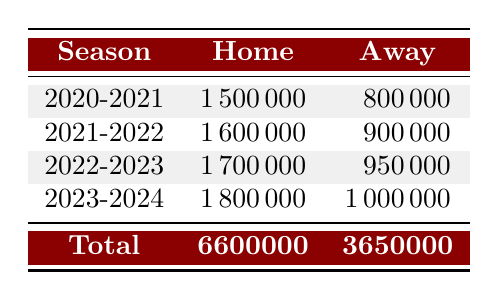What was the total ticket sales revenue for the 2021-2022 season? To find the total revenue for the 2021-2022 season, we add the home and away revenues: 1600000 (Home) + 900000 (Away) = 2500000.
Answer: 2500000 Which match type generated more revenue in the 2022-2023 season? In the 2022-2023 season, home revenue is 1700000 and away revenue is 950000. Since 1700000 is greater than 950000, home matches generated more revenue.
Answer: Home What is the difference in revenue between home matches and away matches for the 2023-2024 season? The home revenue for the 2023-2024 season is 1800000 and the away revenue is 1000000. The difference is calculated as 1800000 - 1000000 = 800000.
Answer: 800000 Was the total revenue from home matches for all seasons greater than 7000000? The total home revenue is 1500000 + 1600000 + 1700000 + 1800000 = 6600000, which is less than 7000000.
Answer: No In which season did the away match revenue see the highest increase compared to the previous season? We compare the away revenues for each season: 800000 (2020-2021), 900000 (2021-2022, increase of 100000), 950000 (2022-2023, increase of 50000), and 1000000 (2023-2024, increase of 50000). The highest increase is from 2020-2021 to 2021-2022, an increase of 100000.
Answer: 2021-2022 What was the average revenue for home matches over the seasons listed? The home revenues are 1500000, 1600000, 1700000, and 1800000. We sum these values to get 6600000 and then divide by the number of seasons (4) to get 6600000 / 4 = 1650000.
Answer: 1650000 Was the away revenue for the 2023-2024 season higher than that of the 2021-2022 season? The away revenue for 2023-2024 is 1000000 and for 2021-2022 is 900000. Since 1000000 is greater than 900000, the statement is true.
Answer: Yes How much did the total ticket sales revenue increase from the 2020-2021 season to the 2023-2024 season? The total revenue for 2020-2021 is 1500000 + 800000 = 2300000 and for 2023-2024 is 1800000 + 1000000 = 2800000. The increase is 2800000 - 2300000 = 500000.
Answer: 500000 